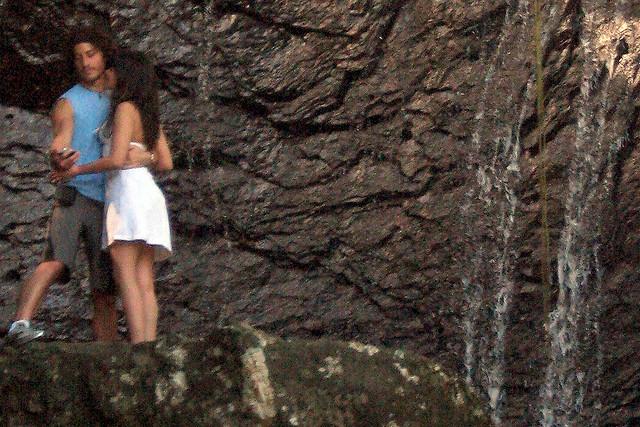Is it cold outside?
Short answer required. No. What is the woman stepping on?
Be succinct. Rock. What is he doing with the object in his right hand?
Write a very short answer. Taking picture. Is this setting romantic?
Answer briefly. Yes. What are the people setting up for?
Keep it brief. Picture. Is anybody in the photo facing the camera?
Write a very short answer. No. Is this couple dancing?
Be succinct. No. 